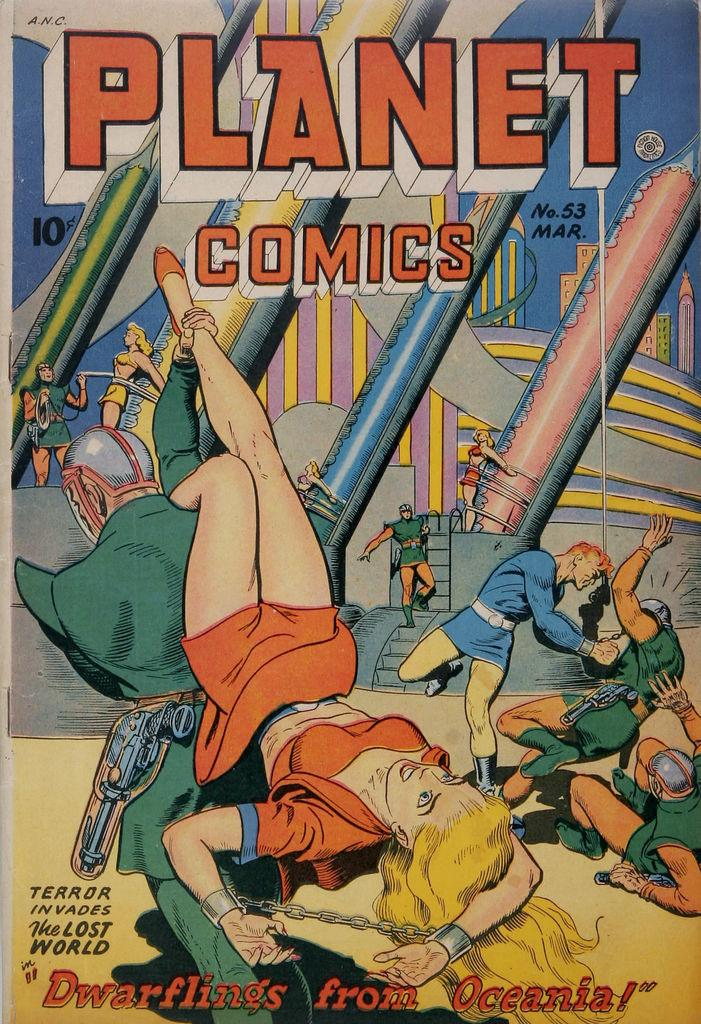<image>
Offer a succinct explanation of the picture presented. Planet Comics book entitled Dwarflings from Oceania the Terror invades the Lost World 